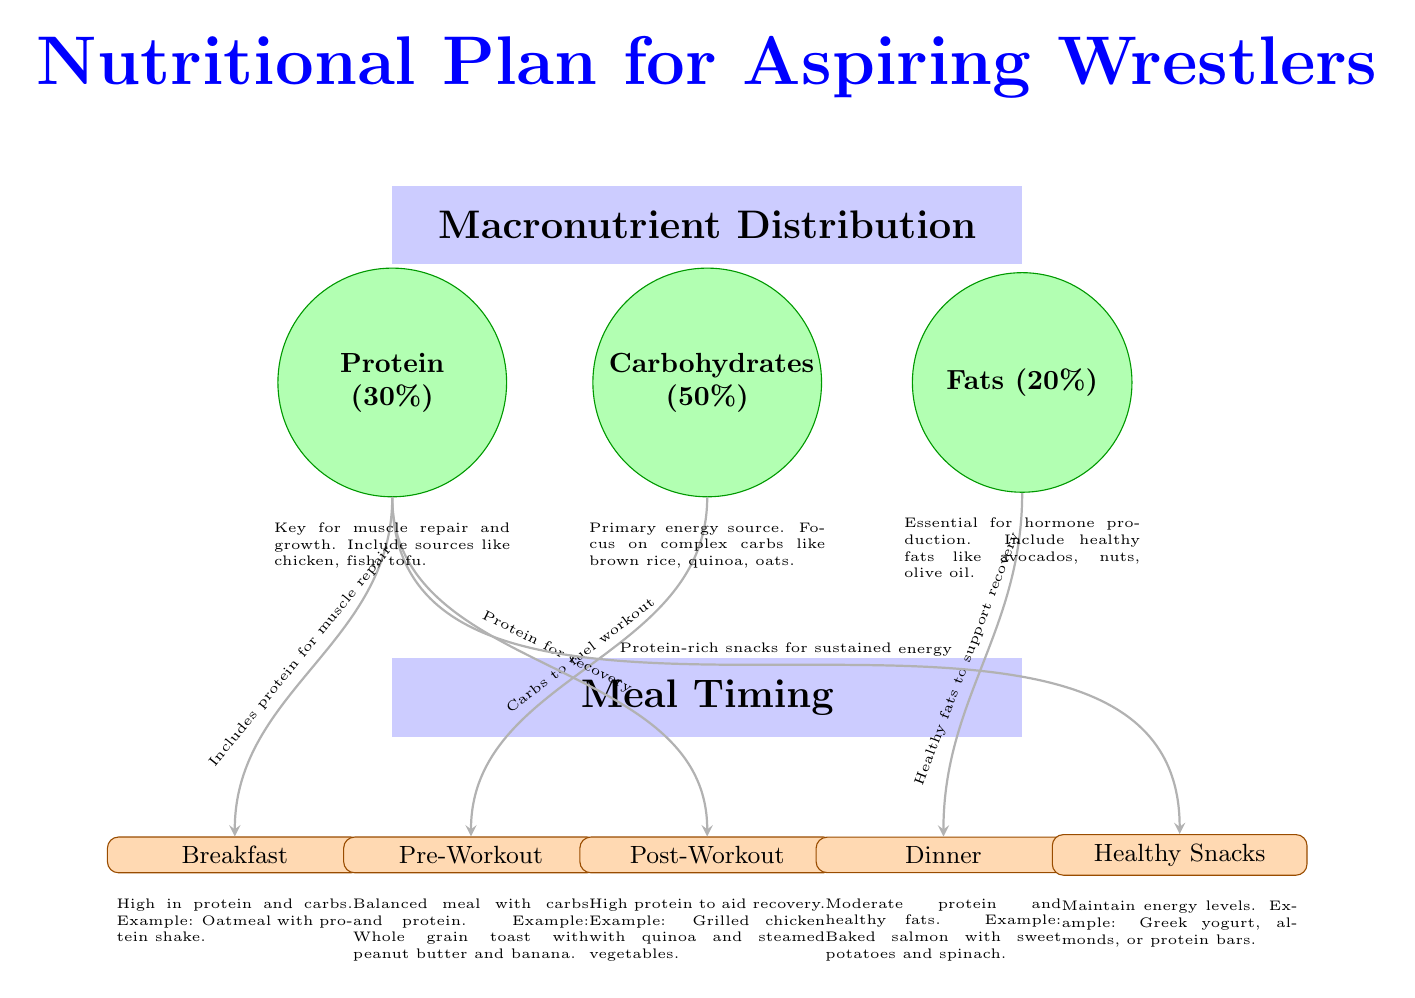What is the percentage of Carbohydrates in the macronutrient distribution? The diagram explicitly states that Carbohydrates make up 50% of the macronutrient distribution.
Answer: 50% How many meals are listed in the meal timing section? By counting the nodes labeled as meals, there are a total of five meals: Breakfast, Pre-Workout, Post-Workout, Dinner, and Snacks.
Answer: 5 What macronutrient is aimed at aiding recovery after a workout? The diagram indicates that Protein is included for recovery in the Post-Workout meal section.
Answer: Protein What type of meal is recommended for breakfast based on the diagram? The diagram suggests a high protein and carb meal for breakfast, giving an example of Oatmeal with protein shake.
Answer: High in protein and carbs Which macronutrient is associated with healthy fats to support recovery? The diagram connects Fats with the Dinner meal, mentioning healthy fats to support recovery.
Answer: Fats How is the Pre-Workout meal characterized in the diagram? The diagram describes the Pre-Workout meal as a balanced meal with carbs and protein, specifically noting an example of Whole grain toast with peanut butter and banana.
Answer: Balanced meal with carbs and protein Which nutrient is emphasized for muscle repair in the Breakfast meal? The diagram shows Protein is emphasized for muscle repair in the Breakfast meal, stating it includes protein for muscle repair.
Answer: Protein What examples are given for healthy snacks in the diagram? The diagram mentions Greek yogurt, almonds, or protein bars as examples of healthy snacks to maintain energy levels.
Answer: Greek yogurt, almonds, or protein bars What is the role of Carbohydrates in the Pre-Workout meal according to the diagram? The diagram indicates that Carbs are provided to fuel the workout in the Pre-Workout meal section.
Answer: Fuel workout 